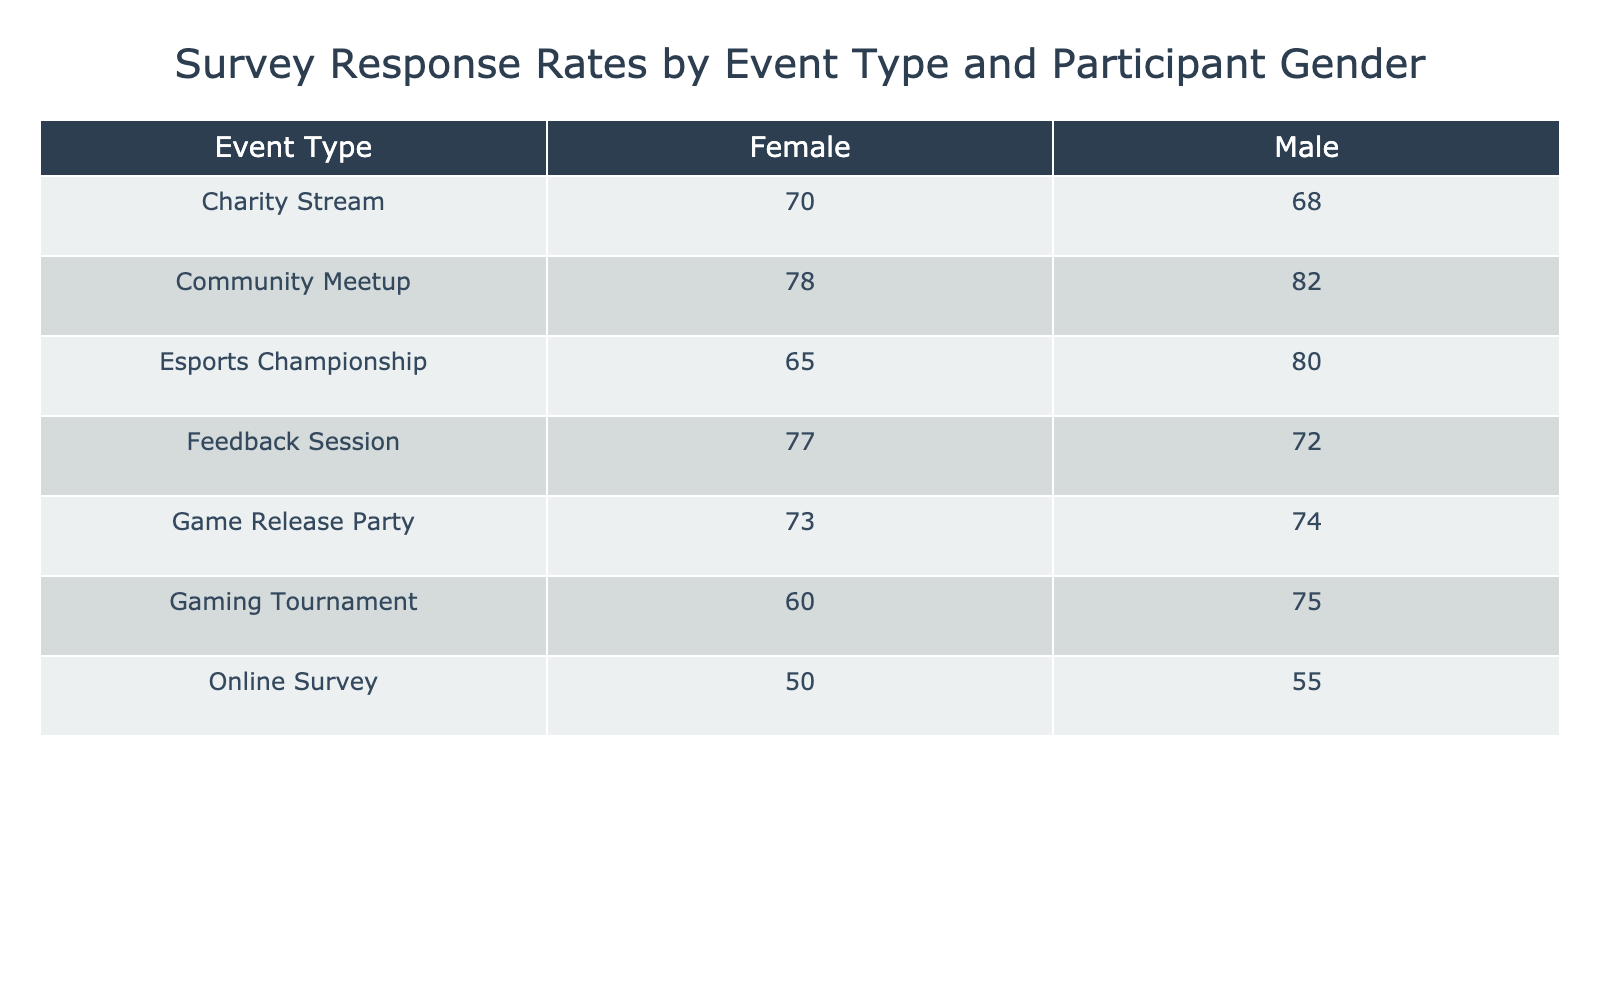What is the response rate for females in the Gaming Tournament? The table indicates that for the Gaming Tournament event, the response rate for females is 60.
Answer: 60 What is the response rate for males during the Community Meetup? According to the table, the Community Meetup has a response rate of 82 for males.
Answer: 82 Which event had the highest response rate among females? By examining the table, the Community Meetup has the highest response rate among females at 78, higher than any other event listed.
Answer: 78 What is the average response rate for males across all events? To find the average, we sum all male response rates: 75 + 68 + 82 + 55 + 80 + 72 + 74 = 486. There are 7 events, so the average is 486 / 7 = 69.43, which can be rounded to 69.
Answer: 69 Is the response rate for males in the Esports Championship higher than in the Charity Stream? The response rate for males in the Esports Championship is 80, and in the Charity Stream, it is 68. Since 80 is greater than 68, the fact is yes.
Answer: Yes How does the average response rate for males compare to that for females? We have already calculated the average response rate for males as 69.43. Next, we calculate the average for females: 60 + 70 + 78 + 50 + 65 + 77 + 73 = 573. There are 7 events, so the average for females is 573 / 7 = 81.86, which is significantly higher than the average for males.
Answer: Males have a lower average response rate Which participant gender had a higher response rate at the Game Release Party? The Game Release Party shows a response rate of 74 for males and 73 for females. Males have a slightly higher response rate compared to females.
Answer: Males What is the difference in response rates for males and females in the Feedback Session? In the Feedback Session, males have a response rate of 72 and females have 77. The difference is 77 - 72 = 5.
Answer: 5 What event type shows the largest disparity in response rates between males and females? Looking across the table, the Feedback Session shows a response rate of 72 for males and 77 for females, giving a disparity of 5. The Community Meetup has a difference of 4 (82 for males and 78 for females). Thus, the Feedback Session has the largest disparity in response rates.
Answer: Feedback Session 